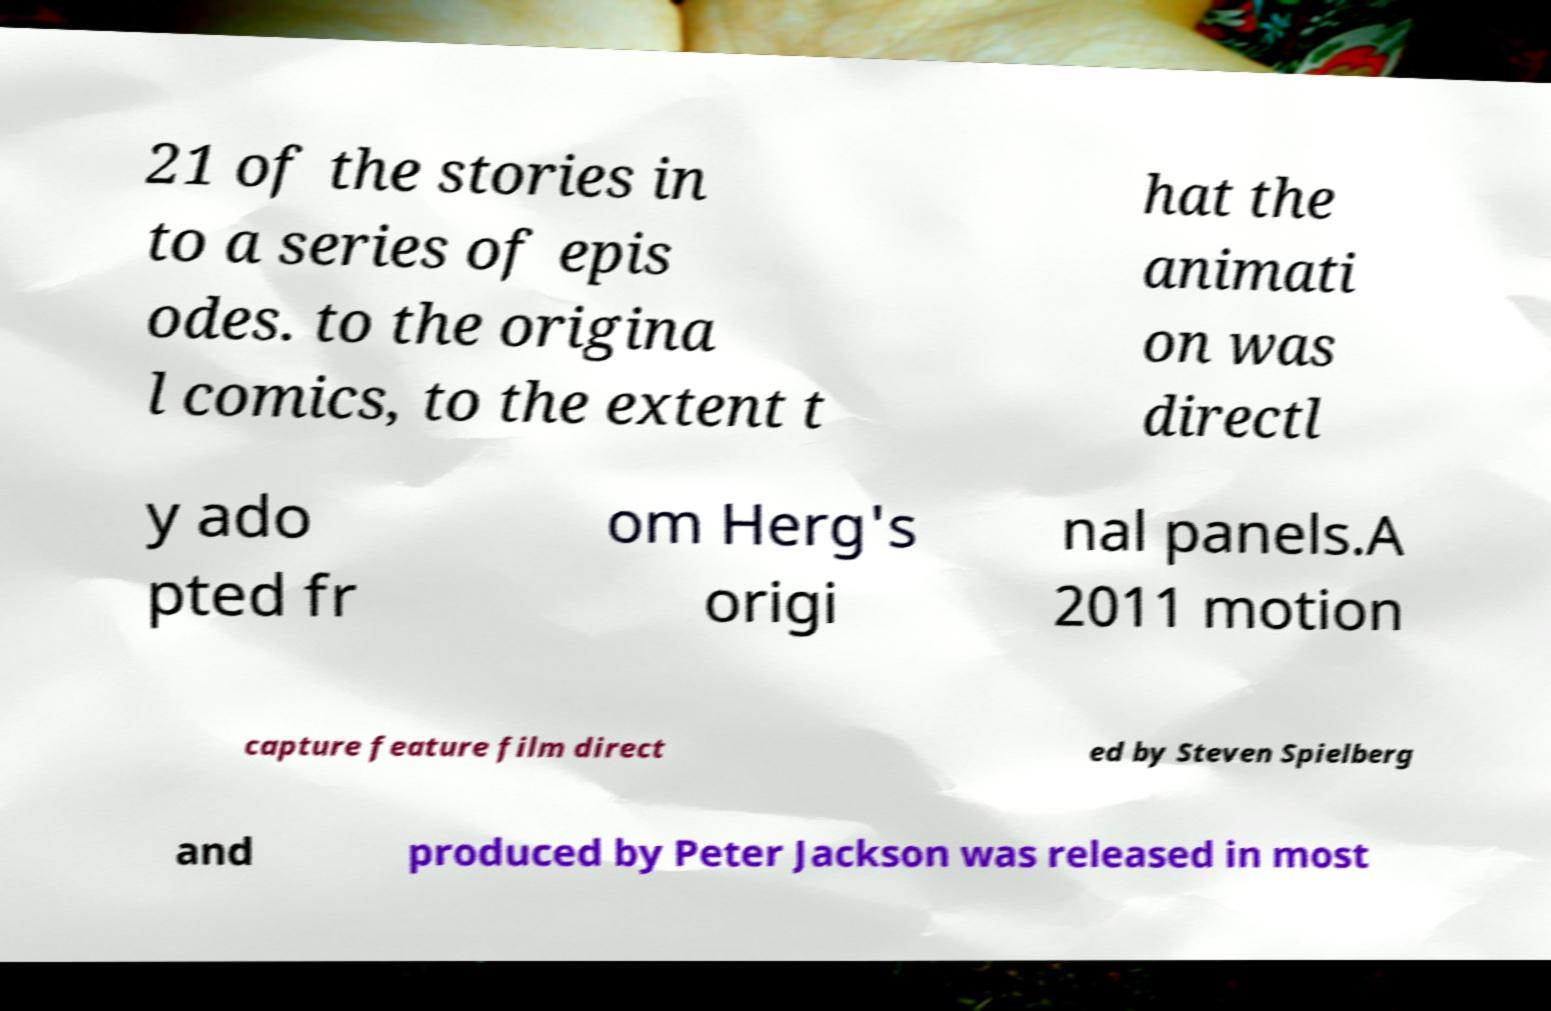For documentation purposes, I need the text within this image transcribed. Could you provide that? 21 of the stories in to a series of epis odes. to the origina l comics, to the extent t hat the animati on was directl y ado pted fr om Herg's origi nal panels.A 2011 motion capture feature film direct ed by Steven Spielberg and produced by Peter Jackson was released in most 